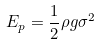<formula> <loc_0><loc_0><loc_500><loc_500>E _ { p } = \frac { 1 } { 2 } \rho g \sigma ^ { 2 }</formula> 